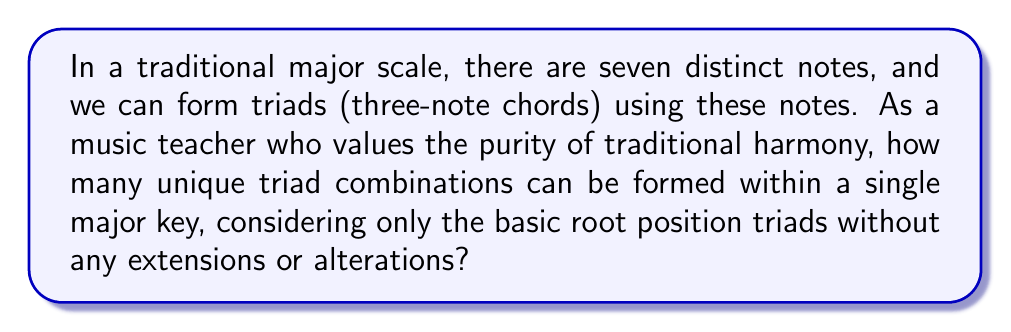Can you answer this question? Let's approach this step-by-step:

1) In a major scale, we have 7 distinct notes. Let's label them 1 through 7.

2) A triad consists of three notes: the root, the third, and the fifth.

3) To form a triad, we start on any of the 7 scale degrees and stack two thirds above it.

4) In a major scale, we can form the following triads:
   - I (major)
   - ii (minor)
   - iii (minor)
   - IV (major)
   - V (major)
   - vi (minor)
   - vii° (diminished)

5) Each of these triads is unique and uses a different root note.

6) The number of possible triads is equal to the number of notes in the scale, as we can form one triad starting on each scale degree.

Therefore, the number of unique triad combinations in a major key is 7.

This can be expressed mathematically as:

$$ \text{Number of triads} = \text{Number of scale degrees} = 7 $$

This approach preserves the traditional harmony structure without venturing into more complex or potentially "dissonant" chord structures that might be considered less appropriate in certain conservative musical contexts.
Answer: 7 unique triad combinations 